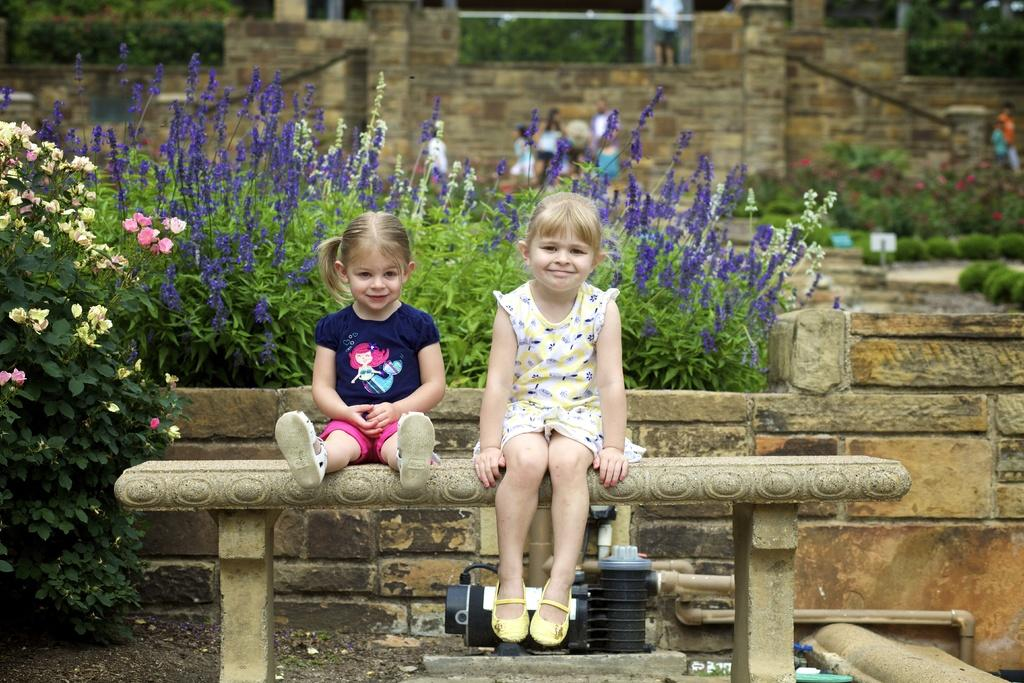How many people are sitting on the bench in the image? There are two persons sitting on a bench in the image. What can be seen behind the persons sitting on the bench? There are plants at the backside of the persons. What is visible in the background of the image? There is a wall in the background of the image. Reasoning: Let't: Let's think step by step in order to produce the conversation. We start by identifying the main subjects in the image, which are the two persons sitting on the bench. Then, we describe the objects and elements that are visible behind and around them, such as the plants and the wall. Each question is designed to elicit a specific detail about the image that is known from the provided facts. Absurd Question/Answer: What type of bomb is hidden behind the plants in the image? There is no bomb present in the image; it only features two persons sitting on a bench and plants behind them. 